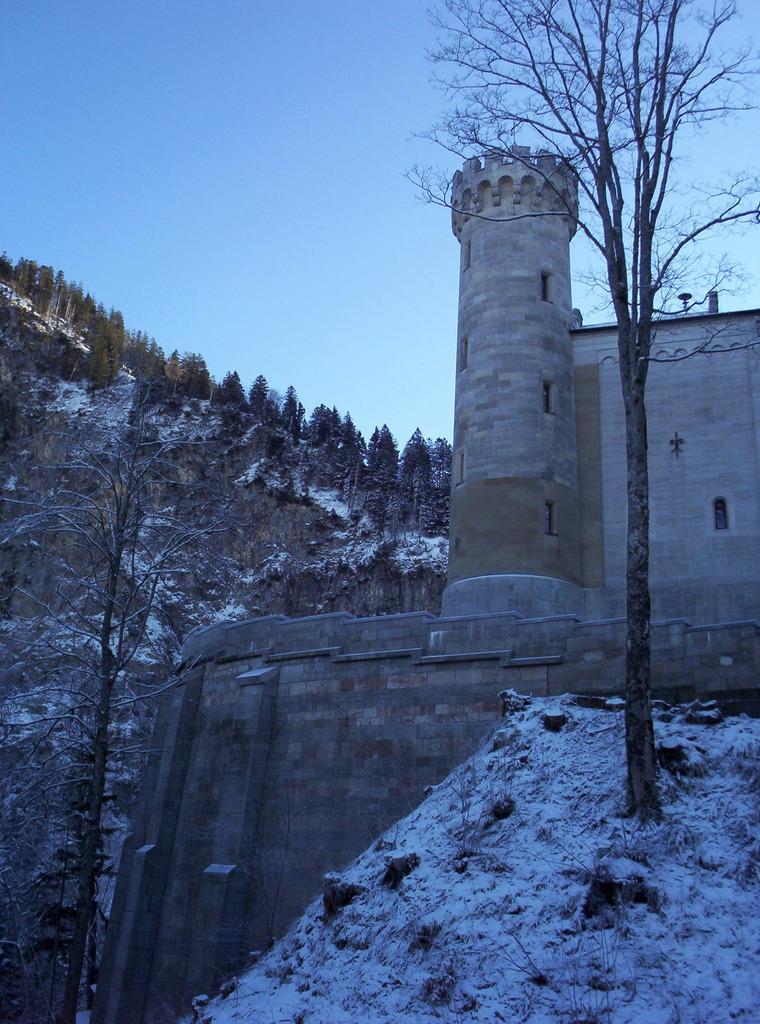How would you summarize this image in a sentence or two? In this picture we can see a fort. We can see trees and the snow. In the background we can see the sky. 